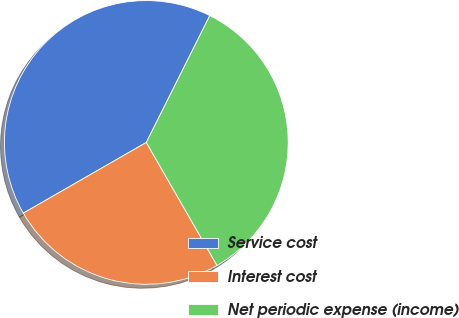Convert chart to OTSL. <chart><loc_0><loc_0><loc_500><loc_500><pie_chart><fcel>Service cost<fcel>Interest cost<fcel>Net periodic expense (income)<nl><fcel>40.69%<fcel>25.0%<fcel>34.31%<nl></chart> 